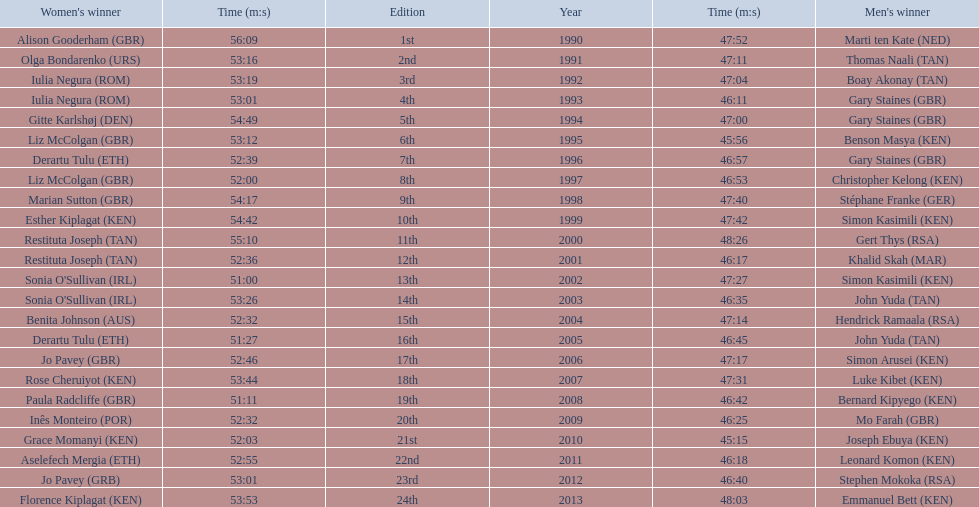What place did sonia o'sullivan finish in 2003? 14th. How long did it take her to finish? 53:26. 